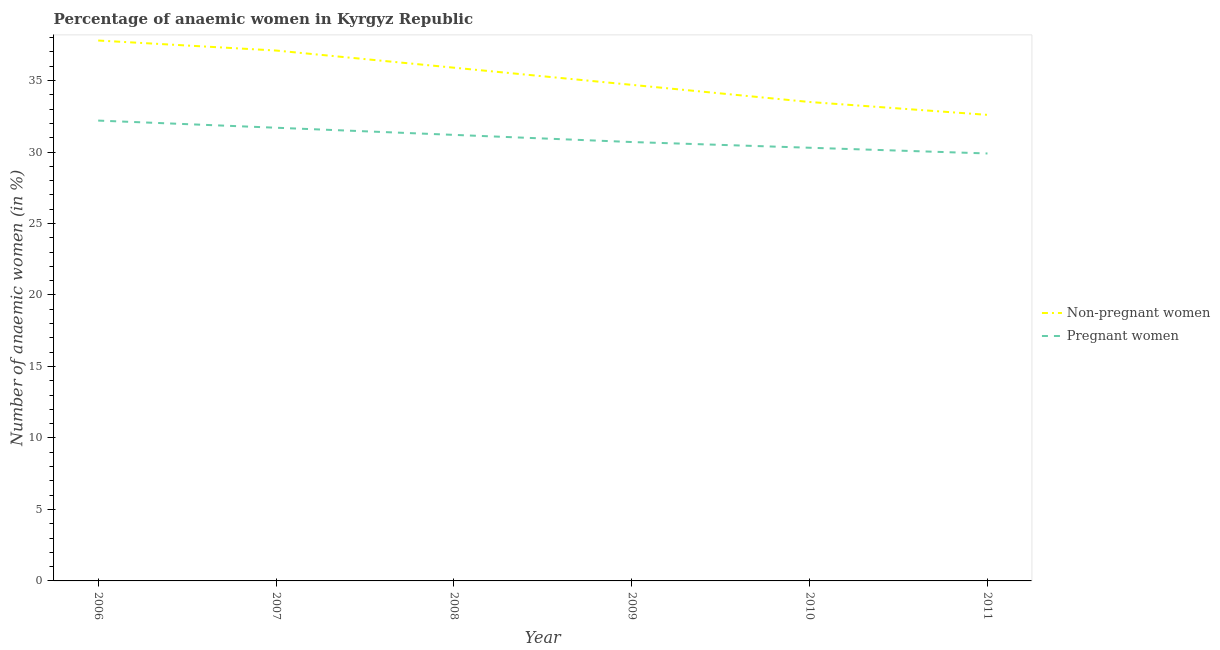Does the line corresponding to percentage of non-pregnant anaemic women intersect with the line corresponding to percentage of pregnant anaemic women?
Give a very brief answer. No. Is the number of lines equal to the number of legend labels?
Your response must be concise. Yes. What is the percentage of non-pregnant anaemic women in 2006?
Offer a terse response. 37.8. Across all years, what is the maximum percentage of pregnant anaemic women?
Offer a terse response. 32.2. Across all years, what is the minimum percentage of non-pregnant anaemic women?
Keep it short and to the point. 32.6. In which year was the percentage of non-pregnant anaemic women minimum?
Ensure brevity in your answer.  2011. What is the total percentage of non-pregnant anaemic women in the graph?
Your answer should be compact. 211.6. What is the difference between the percentage of pregnant anaemic women in 2008 and that in 2010?
Offer a very short reply. 0.9. What is the difference between the percentage of pregnant anaemic women in 2007 and the percentage of non-pregnant anaemic women in 2008?
Your response must be concise. -4.2. What is the average percentage of non-pregnant anaemic women per year?
Provide a succinct answer. 35.27. In the year 2006, what is the difference between the percentage of pregnant anaemic women and percentage of non-pregnant anaemic women?
Provide a succinct answer. -5.6. What is the ratio of the percentage of non-pregnant anaemic women in 2006 to that in 2009?
Offer a terse response. 1.09. Is the difference between the percentage of pregnant anaemic women in 2008 and 2011 greater than the difference between the percentage of non-pregnant anaemic women in 2008 and 2011?
Offer a terse response. No. What is the difference between the highest and the second highest percentage of non-pregnant anaemic women?
Your response must be concise. 0.7. What is the difference between the highest and the lowest percentage of pregnant anaemic women?
Provide a short and direct response. 2.3. Is the percentage of non-pregnant anaemic women strictly greater than the percentage of pregnant anaemic women over the years?
Your response must be concise. Yes. How many lines are there?
Offer a terse response. 2. How many years are there in the graph?
Provide a succinct answer. 6. What is the difference between two consecutive major ticks on the Y-axis?
Ensure brevity in your answer.  5. Are the values on the major ticks of Y-axis written in scientific E-notation?
Keep it short and to the point. No. What is the title of the graph?
Keep it short and to the point. Percentage of anaemic women in Kyrgyz Republic. Does "IMF nonconcessional" appear as one of the legend labels in the graph?
Ensure brevity in your answer.  No. What is the label or title of the Y-axis?
Keep it short and to the point. Number of anaemic women (in %). What is the Number of anaemic women (in %) of Non-pregnant women in 2006?
Your answer should be compact. 37.8. What is the Number of anaemic women (in %) in Pregnant women in 2006?
Provide a succinct answer. 32.2. What is the Number of anaemic women (in %) in Non-pregnant women in 2007?
Provide a short and direct response. 37.1. What is the Number of anaemic women (in %) of Pregnant women in 2007?
Offer a very short reply. 31.7. What is the Number of anaemic women (in %) in Non-pregnant women in 2008?
Make the answer very short. 35.9. What is the Number of anaemic women (in %) in Pregnant women in 2008?
Offer a very short reply. 31.2. What is the Number of anaemic women (in %) in Non-pregnant women in 2009?
Ensure brevity in your answer.  34.7. What is the Number of anaemic women (in %) in Pregnant women in 2009?
Give a very brief answer. 30.7. What is the Number of anaemic women (in %) of Non-pregnant women in 2010?
Offer a terse response. 33.5. What is the Number of anaemic women (in %) of Pregnant women in 2010?
Your answer should be compact. 30.3. What is the Number of anaemic women (in %) in Non-pregnant women in 2011?
Provide a succinct answer. 32.6. What is the Number of anaemic women (in %) of Pregnant women in 2011?
Make the answer very short. 29.9. Across all years, what is the maximum Number of anaemic women (in %) of Non-pregnant women?
Provide a succinct answer. 37.8. Across all years, what is the maximum Number of anaemic women (in %) in Pregnant women?
Your answer should be very brief. 32.2. Across all years, what is the minimum Number of anaemic women (in %) of Non-pregnant women?
Give a very brief answer. 32.6. Across all years, what is the minimum Number of anaemic women (in %) of Pregnant women?
Ensure brevity in your answer.  29.9. What is the total Number of anaemic women (in %) in Non-pregnant women in the graph?
Provide a short and direct response. 211.6. What is the total Number of anaemic women (in %) in Pregnant women in the graph?
Give a very brief answer. 186. What is the difference between the Number of anaemic women (in %) of Non-pregnant women in 2006 and that in 2007?
Keep it short and to the point. 0.7. What is the difference between the Number of anaemic women (in %) in Non-pregnant women in 2006 and that in 2009?
Give a very brief answer. 3.1. What is the difference between the Number of anaemic women (in %) in Non-pregnant women in 2007 and that in 2008?
Provide a succinct answer. 1.2. What is the difference between the Number of anaemic women (in %) of Pregnant women in 2007 and that in 2008?
Keep it short and to the point. 0.5. What is the difference between the Number of anaemic women (in %) of Non-pregnant women in 2007 and that in 2009?
Offer a very short reply. 2.4. What is the difference between the Number of anaemic women (in %) of Non-pregnant women in 2007 and that in 2010?
Your answer should be very brief. 3.6. What is the difference between the Number of anaemic women (in %) in Pregnant women in 2007 and that in 2011?
Offer a very short reply. 1.8. What is the difference between the Number of anaemic women (in %) of Pregnant women in 2008 and that in 2010?
Give a very brief answer. 0.9. What is the difference between the Number of anaemic women (in %) of Non-pregnant women in 2008 and that in 2011?
Ensure brevity in your answer.  3.3. What is the difference between the Number of anaemic women (in %) in Pregnant women in 2008 and that in 2011?
Your answer should be compact. 1.3. What is the difference between the Number of anaemic women (in %) in Non-pregnant women in 2009 and that in 2010?
Ensure brevity in your answer.  1.2. What is the difference between the Number of anaemic women (in %) in Pregnant women in 2009 and that in 2010?
Your answer should be compact. 0.4. What is the difference between the Number of anaemic women (in %) in Non-pregnant women in 2009 and that in 2011?
Offer a very short reply. 2.1. What is the difference between the Number of anaemic women (in %) in Pregnant women in 2009 and that in 2011?
Offer a terse response. 0.8. What is the difference between the Number of anaemic women (in %) of Non-pregnant women in 2006 and the Number of anaemic women (in %) of Pregnant women in 2009?
Give a very brief answer. 7.1. What is the difference between the Number of anaemic women (in %) of Non-pregnant women in 2006 and the Number of anaemic women (in %) of Pregnant women in 2010?
Keep it short and to the point. 7.5. What is the difference between the Number of anaemic women (in %) in Non-pregnant women in 2007 and the Number of anaemic women (in %) in Pregnant women in 2008?
Make the answer very short. 5.9. What is the difference between the Number of anaemic women (in %) of Non-pregnant women in 2007 and the Number of anaemic women (in %) of Pregnant women in 2009?
Your answer should be compact. 6.4. What is the difference between the Number of anaemic women (in %) in Non-pregnant women in 2008 and the Number of anaemic women (in %) in Pregnant women in 2010?
Ensure brevity in your answer.  5.6. What is the difference between the Number of anaemic women (in %) in Non-pregnant women in 2009 and the Number of anaemic women (in %) in Pregnant women in 2010?
Ensure brevity in your answer.  4.4. What is the difference between the Number of anaemic women (in %) of Non-pregnant women in 2010 and the Number of anaemic women (in %) of Pregnant women in 2011?
Ensure brevity in your answer.  3.6. What is the average Number of anaemic women (in %) in Non-pregnant women per year?
Ensure brevity in your answer.  35.27. In the year 2007, what is the difference between the Number of anaemic women (in %) of Non-pregnant women and Number of anaemic women (in %) of Pregnant women?
Offer a very short reply. 5.4. In the year 2009, what is the difference between the Number of anaemic women (in %) of Non-pregnant women and Number of anaemic women (in %) of Pregnant women?
Your response must be concise. 4. In the year 2011, what is the difference between the Number of anaemic women (in %) in Non-pregnant women and Number of anaemic women (in %) in Pregnant women?
Ensure brevity in your answer.  2.7. What is the ratio of the Number of anaemic women (in %) in Non-pregnant women in 2006 to that in 2007?
Keep it short and to the point. 1.02. What is the ratio of the Number of anaemic women (in %) in Pregnant women in 2006 to that in 2007?
Your answer should be compact. 1.02. What is the ratio of the Number of anaemic women (in %) of Non-pregnant women in 2006 to that in 2008?
Ensure brevity in your answer.  1.05. What is the ratio of the Number of anaemic women (in %) of Pregnant women in 2006 to that in 2008?
Your response must be concise. 1.03. What is the ratio of the Number of anaemic women (in %) of Non-pregnant women in 2006 to that in 2009?
Provide a short and direct response. 1.09. What is the ratio of the Number of anaemic women (in %) in Pregnant women in 2006 to that in 2009?
Offer a terse response. 1.05. What is the ratio of the Number of anaemic women (in %) of Non-pregnant women in 2006 to that in 2010?
Your answer should be very brief. 1.13. What is the ratio of the Number of anaemic women (in %) in Pregnant women in 2006 to that in 2010?
Your answer should be compact. 1.06. What is the ratio of the Number of anaemic women (in %) of Non-pregnant women in 2006 to that in 2011?
Provide a short and direct response. 1.16. What is the ratio of the Number of anaemic women (in %) of Pregnant women in 2006 to that in 2011?
Make the answer very short. 1.08. What is the ratio of the Number of anaemic women (in %) of Non-pregnant women in 2007 to that in 2008?
Keep it short and to the point. 1.03. What is the ratio of the Number of anaemic women (in %) in Non-pregnant women in 2007 to that in 2009?
Ensure brevity in your answer.  1.07. What is the ratio of the Number of anaemic women (in %) of Pregnant women in 2007 to that in 2009?
Make the answer very short. 1.03. What is the ratio of the Number of anaemic women (in %) in Non-pregnant women in 2007 to that in 2010?
Make the answer very short. 1.11. What is the ratio of the Number of anaemic women (in %) in Pregnant women in 2007 to that in 2010?
Make the answer very short. 1.05. What is the ratio of the Number of anaemic women (in %) in Non-pregnant women in 2007 to that in 2011?
Your answer should be very brief. 1.14. What is the ratio of the Number of anaemic women (in %) of Pregnant women in 2007 to that in 2011?
Your response must be concise. 1.06. What is the ratio of the Number of anaemic women (in %) in Non-pregnant women in 2008 to that in 2009?
Make the answer very short. 1.03. What is the ratio of the Number of anaemic women (in %) in Pregnant women in 2008 to that in 2009?
Your response must be concise. 1.02. What is the ratio of the Number of anaemic women (in %) of Non-pregnant women in 2008 to that in 2010?
Provide a succinct answer. 1.07. What is the ratio of the Number of anaemic women (in %) in Pregnant women in 2008 to that in 2010?
Your response must be concise. 1.03. What is the ratio of the Number of anaemic women (in %) in Non-pregnant women in 2008 to that in 2011?
Ensure brevity in your answer.  1.1. What is the ratio of the Number of anaemic women (in %) in Pregnant women in 2008 to that in 2011?
Provide a succinct answer. 1.04. What is the ratio of the Number of anaemic women (in %) in Non-pregnant women in 2009 to that in 2010?
Your answer should be compact. 1.04. What is the ratio of the Number of anaemic women (in %) in Pregnant women in 2009 to that in 2010?
Your answer should be very brief. 1.01. What is the ratio of the Number of anaemic women (in %) in Non-pregnant women in 2009 to that in 2011?
Give a very brief answer. 1.06. What is the ratio of the Number of anaemic women (in %) in Pregnant women in 2009 to that in 2011?
Make the answer very short. 1.03. What is the ratio of the Number of anaemic women (in %) of Non-pregnant women in 2010 to that in 2011?
Give a very brief answer. 1.03. What is the ratio of the Number of anaemic women (in %) of Pregnant women in 2010 to that in 2011?
Keep it short and to the point. 1.01. What is the difference between the highest and the second highest Number of anaemic women (in %) in Non-pregnant women?
Ensure brevity in your answer.  0.7. What is the difference between the highest and the lowest Number of anaemic women (in %) in Non-pregnant women?
Offer a very short reply. 5.2. 